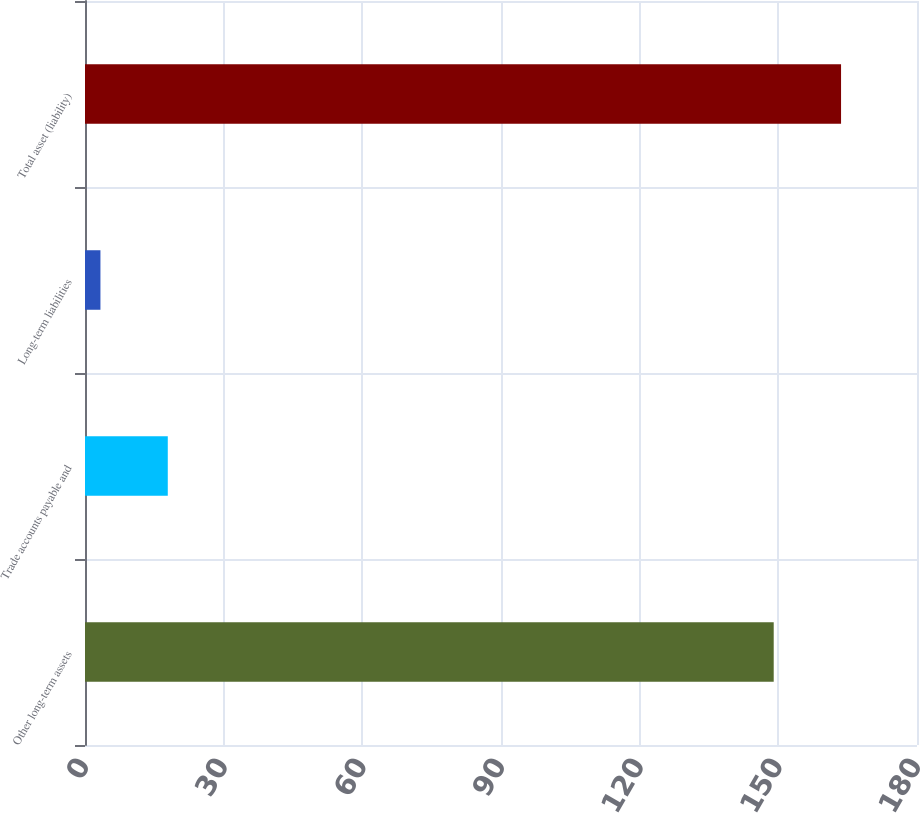<chart> <loc_0><loc_0><loc_500><loc_500><bar_chart><fcel>Other long-term assets<fcel>Trade accounts payable and<fcel>Long-term liabilities<fcel>Total asset (liability)<nl><fcel>149<fcel>17.91<fcel>3.34<fcel>163.57<nl></chart> 